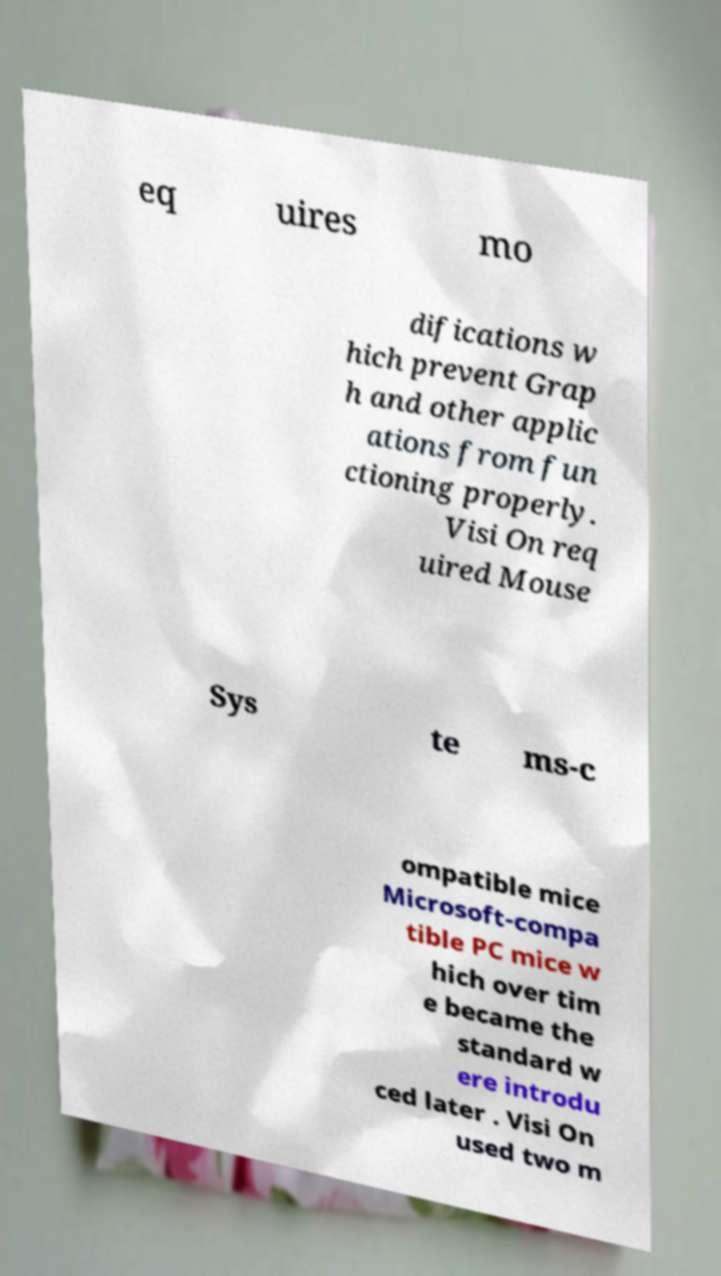Can you read and provide the text displayed in the image?This photo seems to have some interesting text. Can you extract and type it out for me? eq uires mo difications w hich prevent Grap h and other applic ations from fun ctioning properly. Visi On req uired Mouse Sys te ms-c ompatible mice Microsoft-compa tible PC mice w hich over tim e became the standard w ere introdu ced later . Visi On used two m 